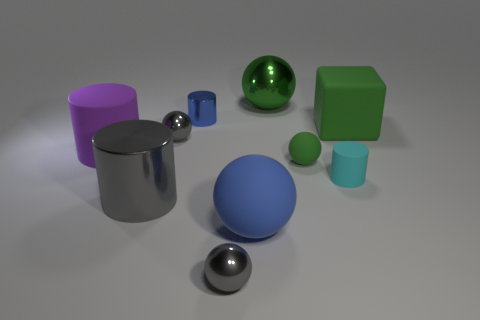Subtract 1 balls. How many balls are left? 4 Subtract all blue spheres. How many spheres are left? 4 Subtract all green metal balls. How many balls are left? 4 Subtract all purple spheres. Subtract all yellow blocks. How many spheres are left? 5 Subtract all cubes. How many objects are left? 9 Subtract all green shiny balls. Subtract all big matte spheres. How many objects are left? 8 Add 7 small blue cylinders. How many small blue cylinders are left? 8 Add 7 rubber blocks. How many rubber blocks exist? 8 Subtract 1 gray cylinders. How many objects are left? 9 